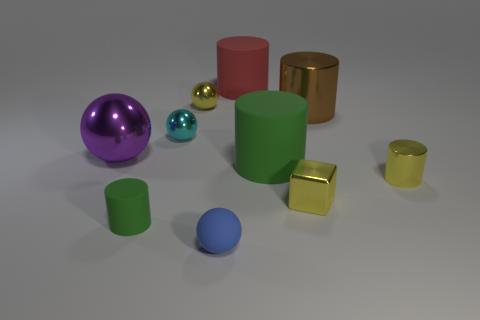Do the yellow metallic sphere and the rubber sphere have the same size?
Offer a very short reply. Yes. Are there any tiny metallic spheres of the same color as the cube?
Give a very brief answer. Yes. There is a small metallic thing that is to the left of the yellow sphere; is it the same shape as the purple thing?
Your answer should be very brief. Yes. How many objects have the same size as the red cylinder?
Ensure brevity in your answer.  3. How many yellow shiny balls are in front of the green rubber cylinder that is behind the small cube?
Offer a terse response. 0. Is the material of the big thing left of the big red rubber object the same as the small green cylinder?
Provide a short and direct response. No. Are the sphere in front of the small metal cylinder and the big thing that is on the left side of the large red object made of the same material?
Your answer should be very brief. No. Is the number of small yellow objects that are in front of the cyan metal thing greater than the number of tiny cyan blocks?
Give a very brief answer. Yes. What color is the cylinder behind the small yellow metal ball that is behind the shiny block?
Your answer should be very brief. Red. There is a blue matte object that is the same size as the yellow ball; what shape is it?
Keep it short and to the point. Sphere. 